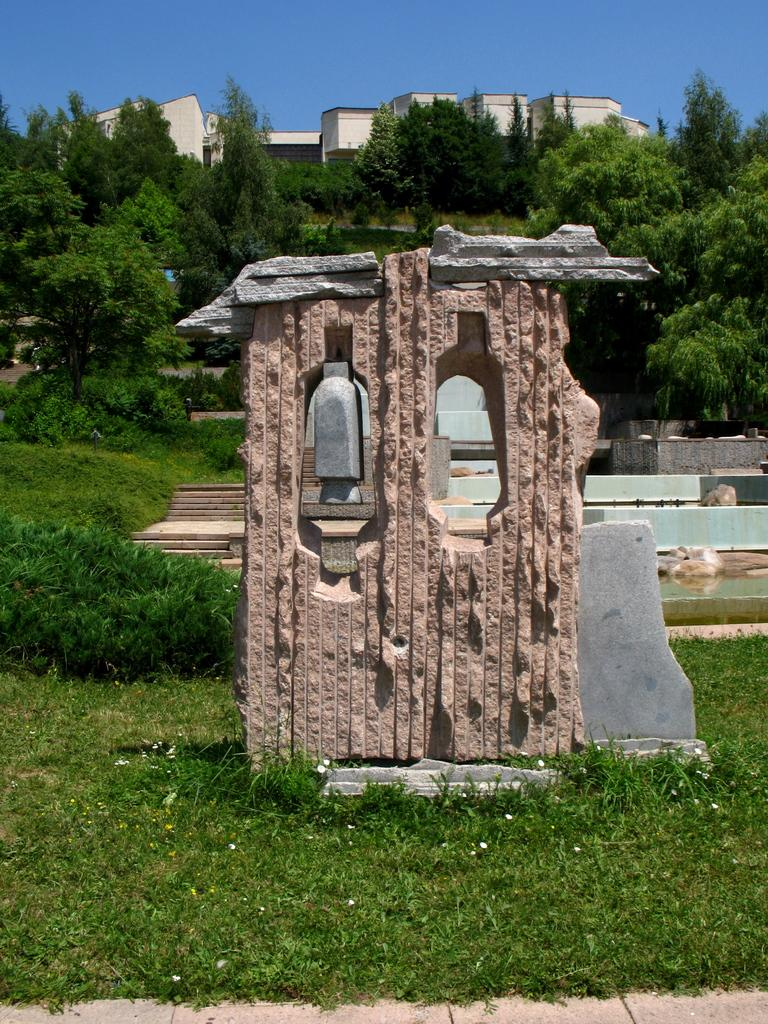What is the main subject of the image? There is a rock in the image. What can be seen in the background of the image? There are trees and buildings in the background of the image. What is the color of the trees in the image? The trees are green. What is the color of the sky in the image? The sky is blue. What type of hook is hanging from the rock in the image? There is no hook present in the image; it features a rock with trees, buildings, and a blue sky in the background. 